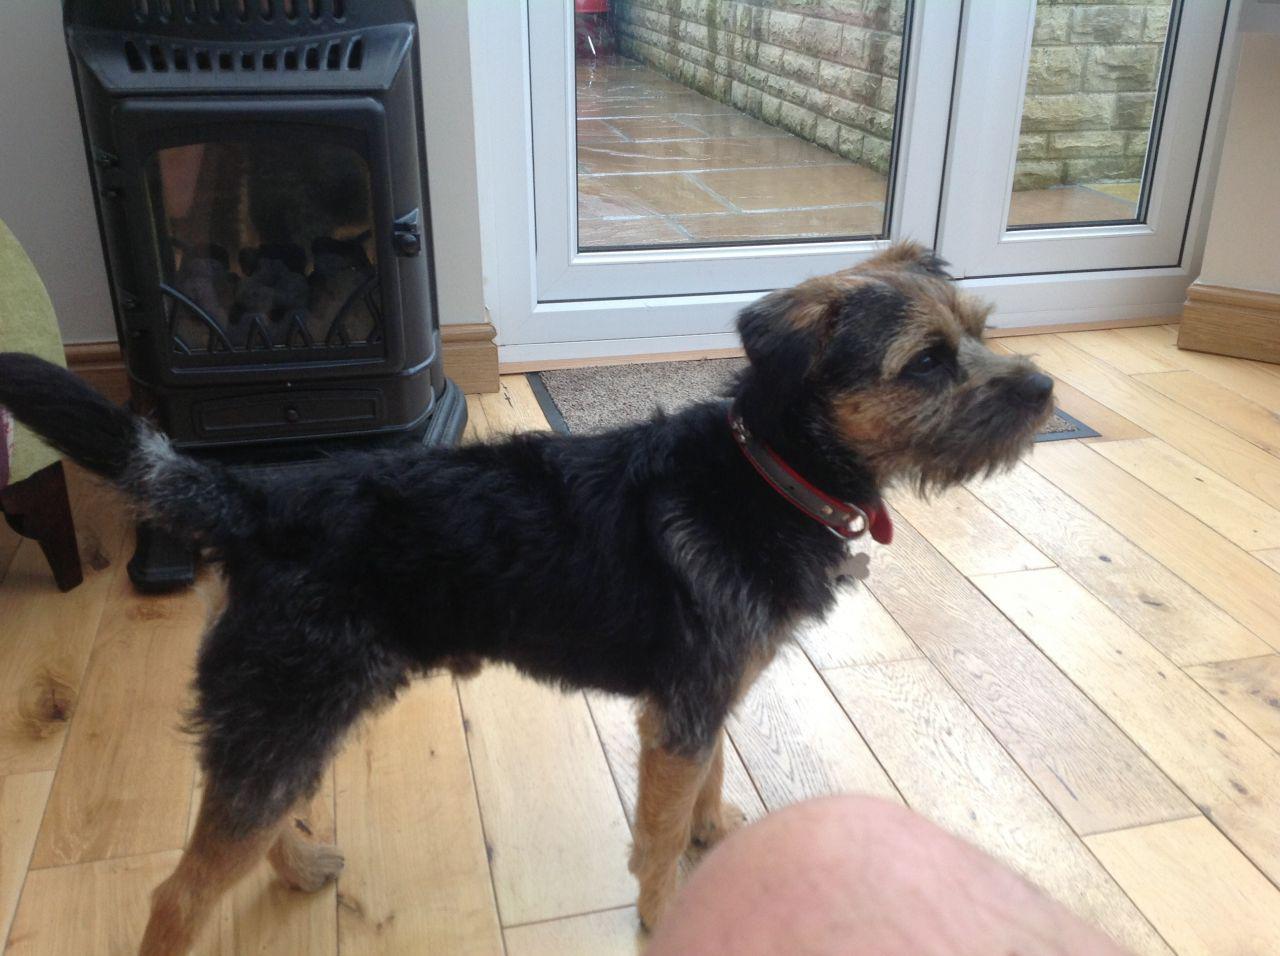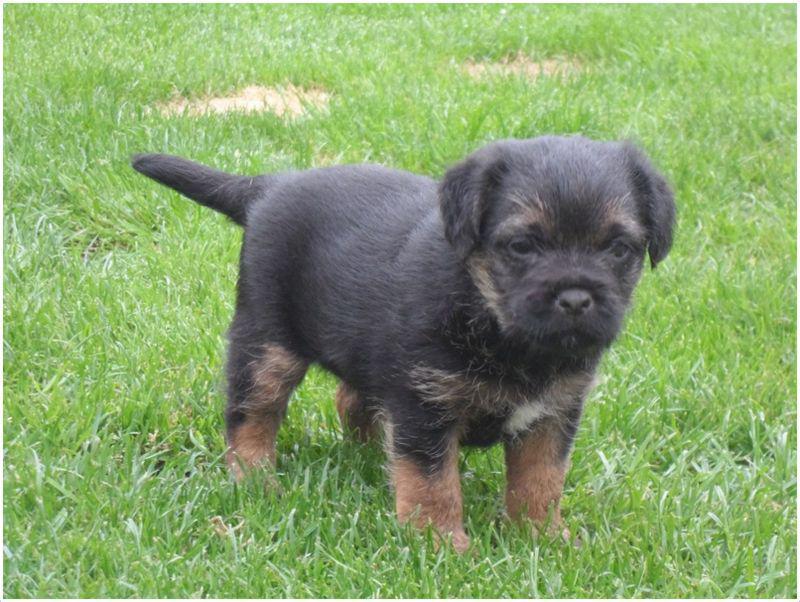The first image is the image on the left, the second image is the image on the right. Analyze the images presented: Is the assertion "One dog is standing in the grass." valid? Answer yes or no. Yes. The first image is the image on the left, the second image is the image on the right. Evaluate the accuracy of this statement regarding the images: "The left image shows a dog with head and body in profile and its tail extended out, and the right image shows a puppy with its tail sticking out behind it.". Is it true? Answer yes or no. Yes. 